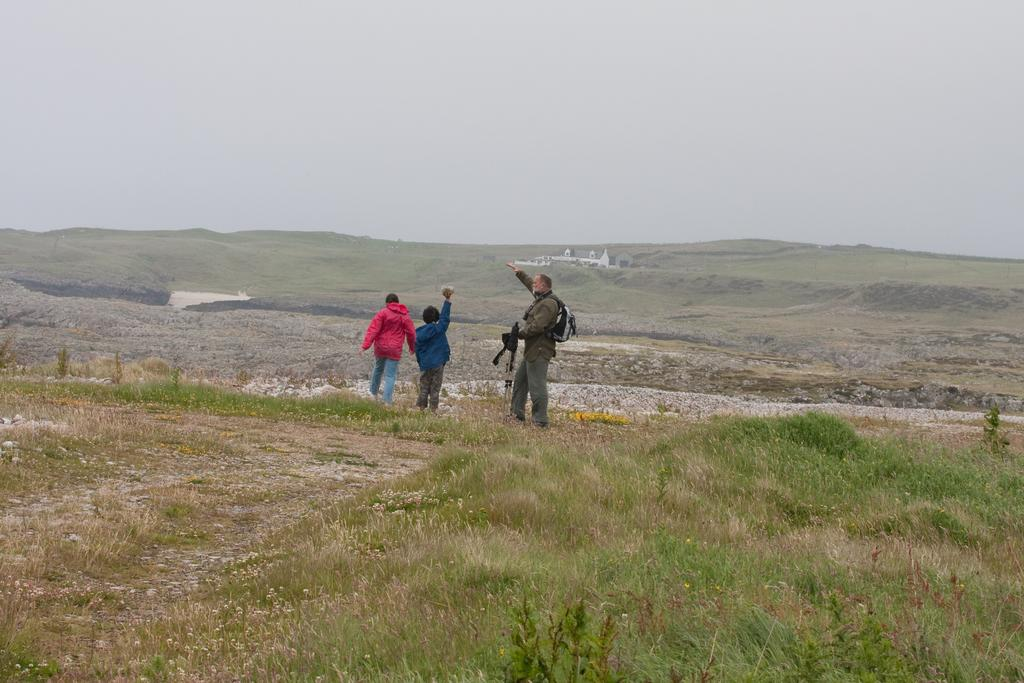How many people are present in the image? There are three persons on the ground in the image. What is the surface they are standing on? The ground is covered with grass. What type of vegetation can be seen in the image? There are plants in the image. What can be seen in the background of the image? The sky is visible in the background. What type of hat is the person in the middle wearing in the image? There is no hat visible on any of the persons in the image. What border is depicted in the image? There is no border present in the image. 